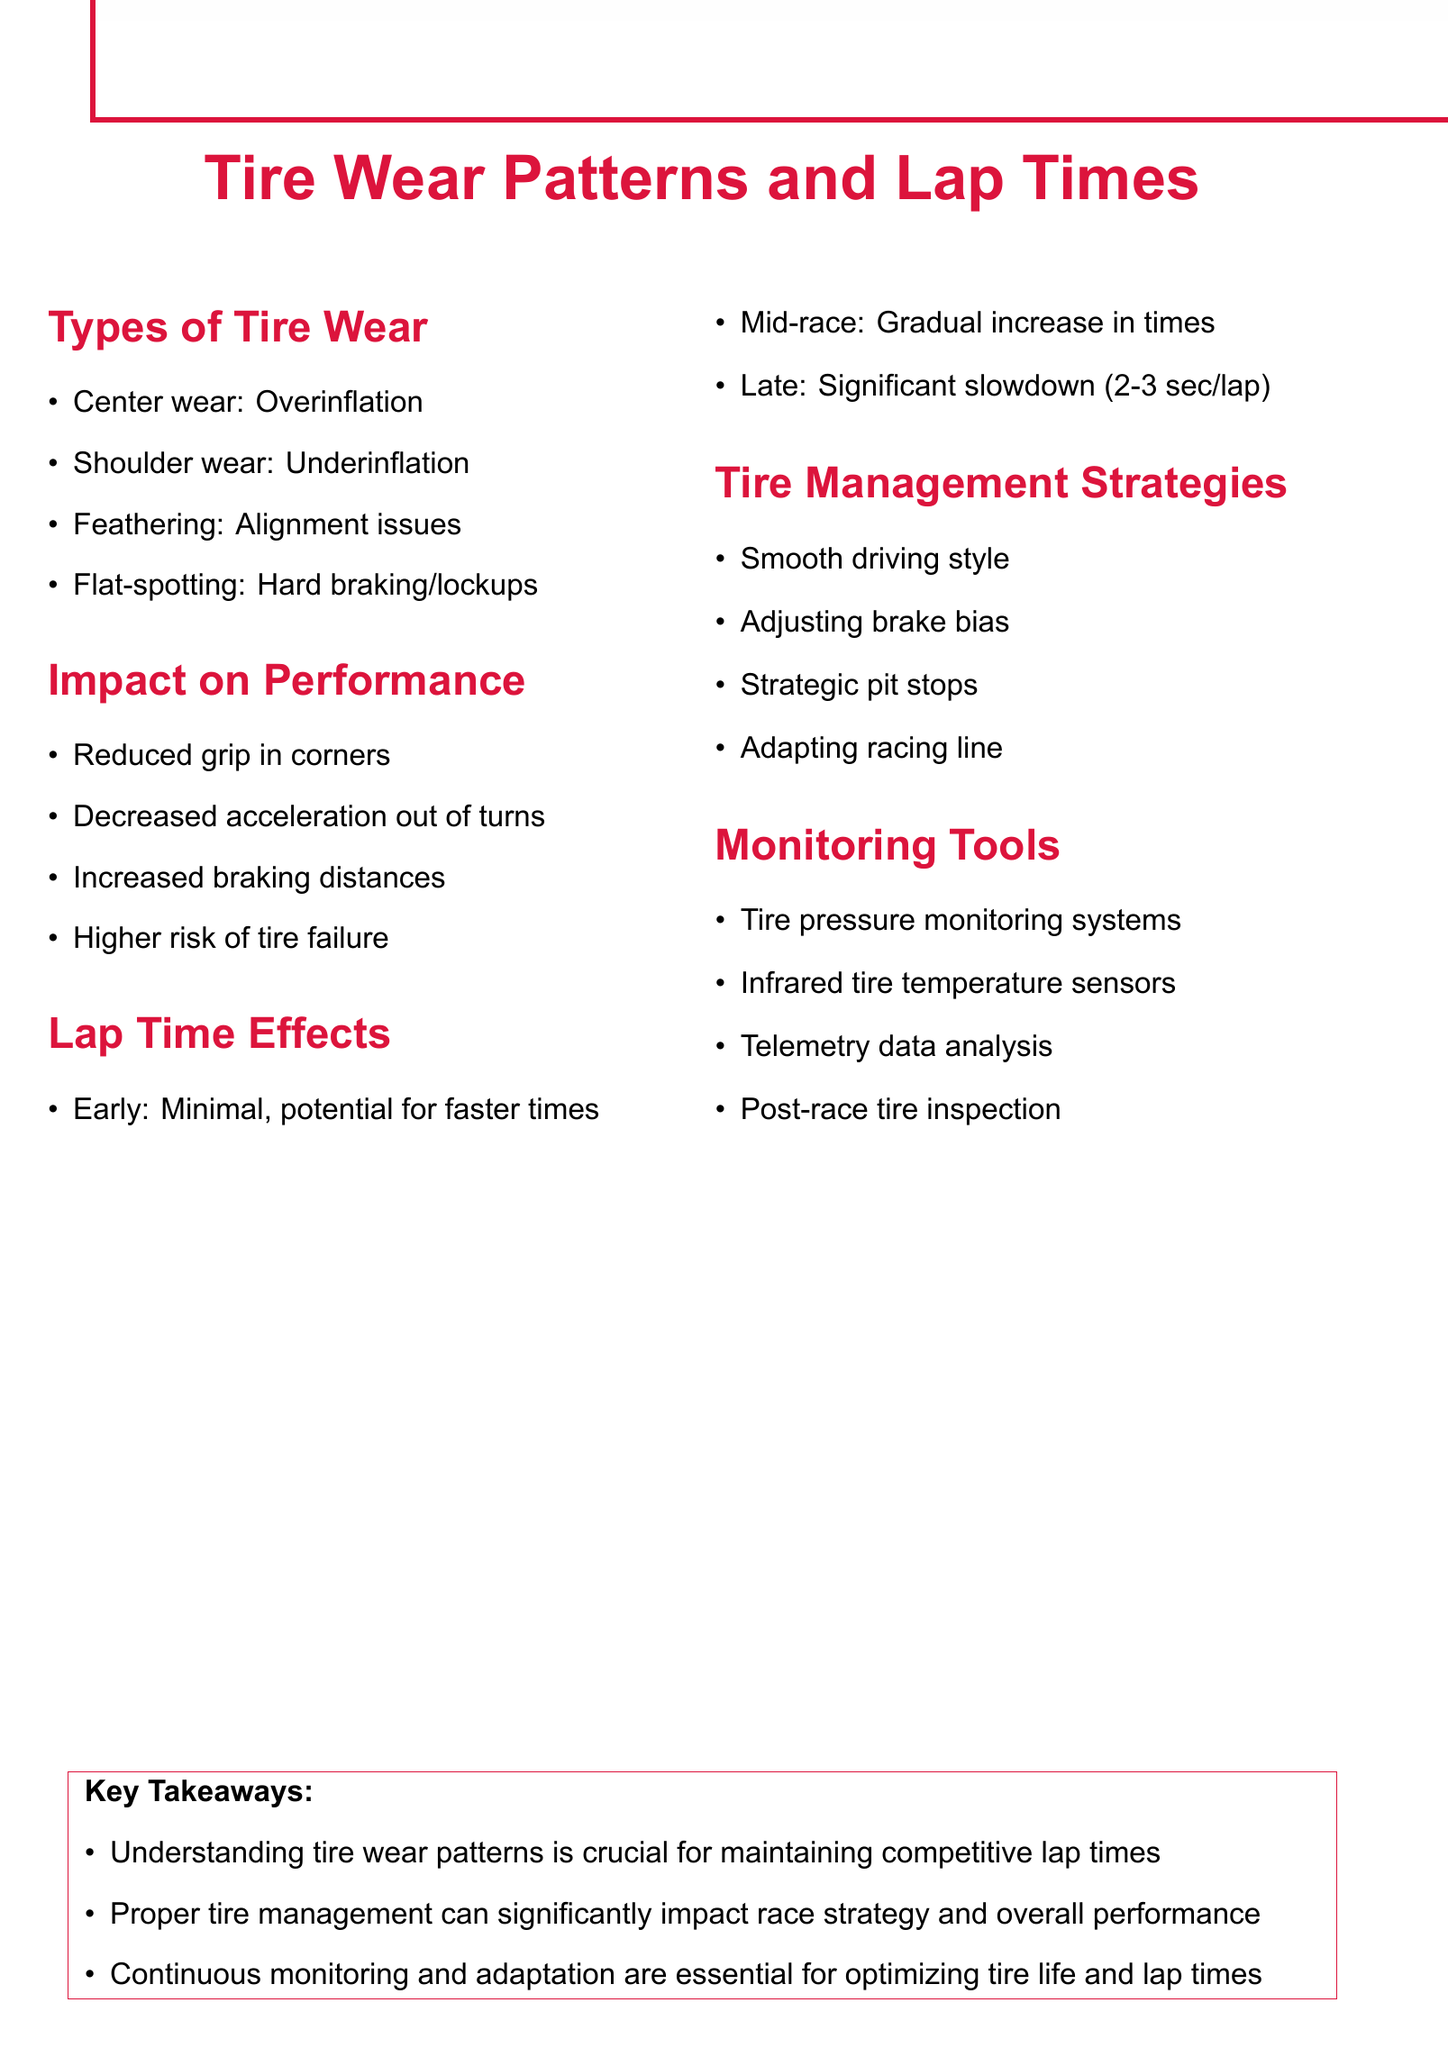What is the first type of tire wear mentioned? The first type of tire wear listed under "Types of Tire Wear" is "Center wear."
Answer: Center wear What causes shoulder wear? According to the document, shoulder wear is caused by underinflation.
Answer: Underinflation What is the maximum lap time slowdown in late race stages? The document states that in late stages, lap times can slow down significantly, up to 2-3 seconds per lap.
Answer: 2-3 seconds Which tire management strategy involves a smoother driving style? The tire management strategy that involves a smoother driving style is mentioned as "Smooth driving style."
Answer: Smooth driving style What tool is used to monitor tire pressure? Tire pressure monitoring systems (TPMS) are used for monitoring tire pressure.
Answer: TPMS What is one impact of tire wear on performance? One impact of tire wear on performance is "Reduced grip in corners."
Answer: Reduced grip in corners What adjustment can reduce flat-spotting? The adjustment that can reduce flat-spotting, as noted in the document, is "Adjusting brake bias."
Answer: Adjusting brake bias What stage of the race shows minimal impact on lap times? The "Early stages" of the race show minimal impact on lap times.
Answer: Early stages What is essential for optimizing tire life according to the key takeaways? Continuous monitoring and adaptation are essential for optimizing tire life and lap times, as stated in the key takeaways.
Answer: Continuous monitoring and adaptation 